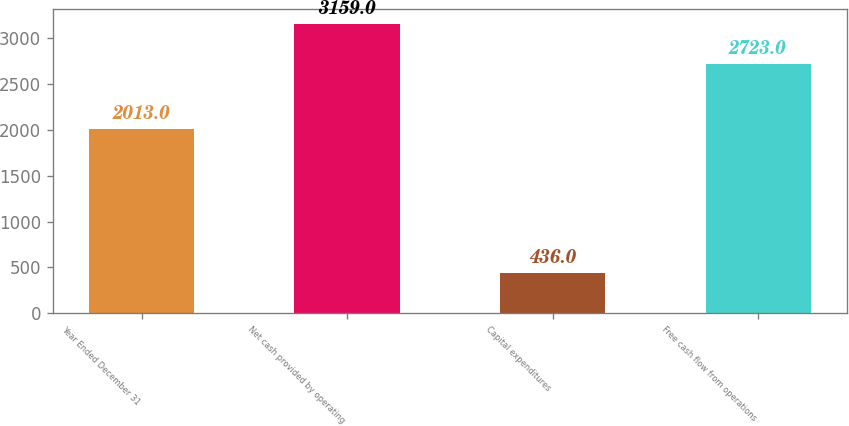Convert chart to OTSL. <chart><loc_0><loc_0><loc_500><loc_500><bar_chart><fcel>Year Ended December 31<fcel>Net cash provided by operating<fcel>Capital expenditures<fcel>Free cash flow from operations<nl><fcel>2013<fcel>3159<fcel>436<fcel>2723<nl></chart> 